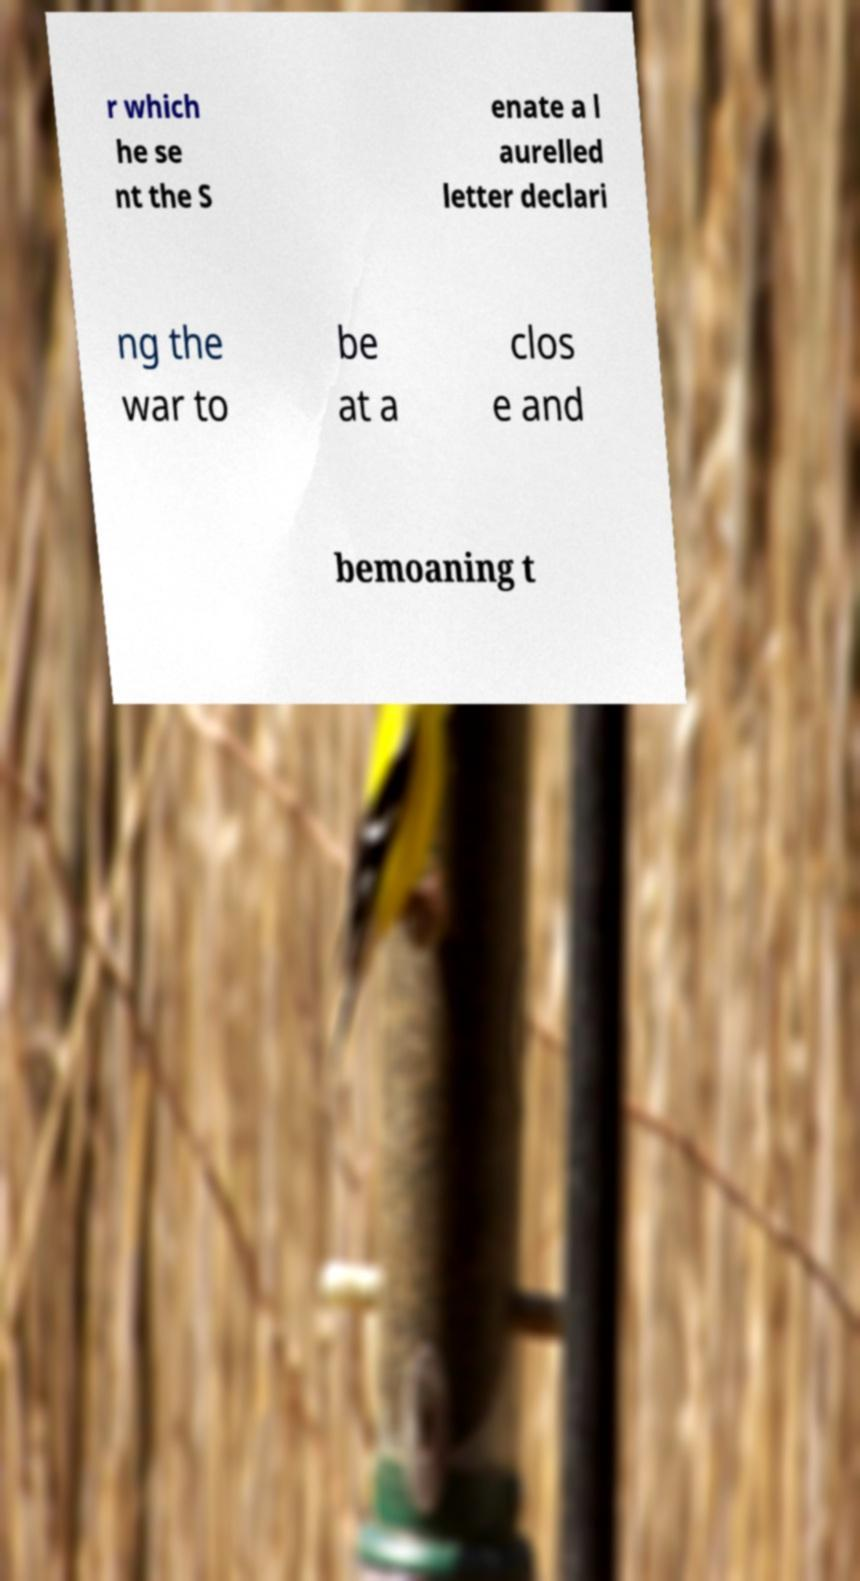Please identify and transcribe the text found in this image. r which he se nt the S enate a l aurelled letter declari ng the war to be at a clos e and bemoaning t 